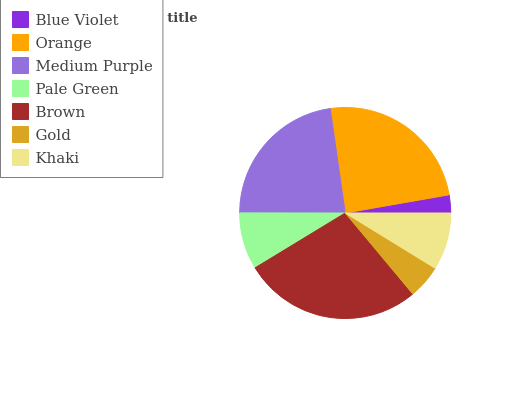Is Blue Violet the minimum?
Answer yes or no. Yes. Is Brown the maximum?
Answer yes or no. Yes. Is Orange the minimum?
Answer yes or no. No. Is Orange the maximum?
Answer yes or no. No. Is Orange greater than Blue Violet?
Answer yes or no. Yes. Is Blue Violet less than Orange?
Answer yes or no. Yes. Is Blue Violet greater than Orange?
Answer yes or no. No. Is Orange less than Blue Violet?
Answer yes or no. No. Is Khaki the high median?
Answer yes or no. Yes. Is Khaki the low median?
Answer yes or no. Yes. Is Pale Green the high median?
Answer yes or no. No. Is Gold the low median?
Answer yes or no. No. 